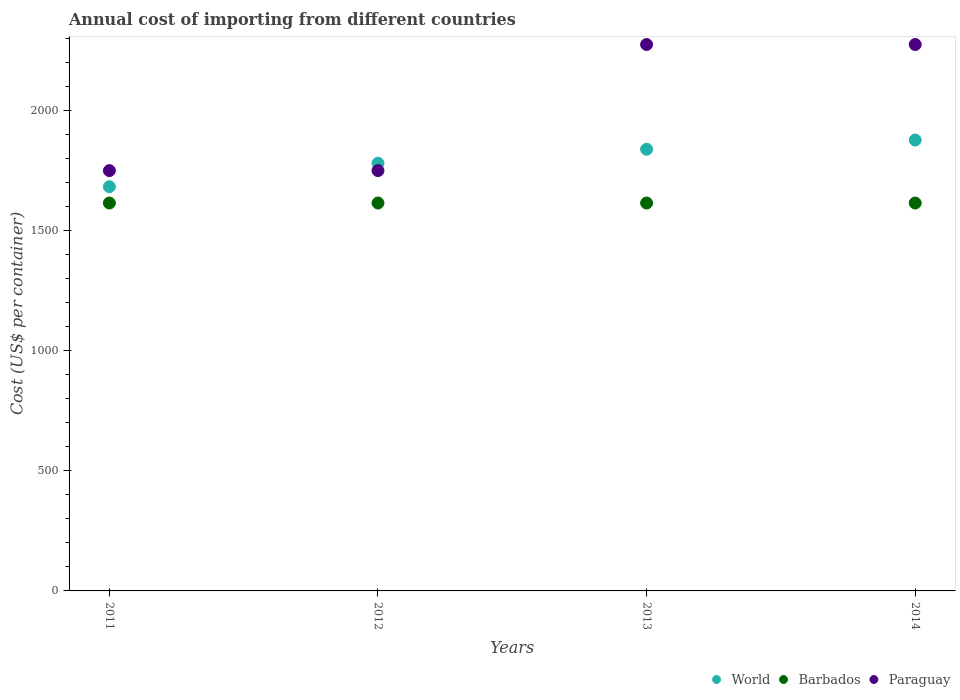How many different coloured dotlines are there?
Provide a short and direct response. 3. What is the total annual cost of importing in World in 2013?
Your answer should be compact. 1838.86. Across all years, what is the maximum total annual cost of importing in Paraguay?
Your response must be concise. 2275. Across all years, what is the minimum total annual cost of importing in Paraguay?
Your answer should be very brief. 1750. In which year was the total annual cost of importing in Paraguay minimum?
Give a very brief answer. 2011. What is the total total annual cost of importing in World in the graph?
Offer a terse response. 7179.65. What is the difference between the total annual cost of importing in World in 2012 and that in 2013?
Keep it short and to the point. -58.16. What is the difference between the total annual cost of importing in Barbados in 2013 and the total annual cost of importing in World in 2014?
Make the answer very short. -262.17. What is the average total annual cost of importing in Paraguay per year?
Your answer should be very brief. 2012.5. In the year 2012, what is the difference between the total annual cost of importing in World and total annual cost of importing in Barbados?
Offer a very short reply. 165.7. What is the ratio of the total annual cost of importing in World in 2011 to that in 2012?
Ensure brevity in your answer.  0.95. Is the difference between the total annual cost of importing in World in 2012 and 2013 greater than the difference between the total annual cost of importing in Barbados in 2012 and 2013?
Provide a succinct answer. No. What is the difference between the highest and the second highest total annual cost of importing in World?
Make the answer very short. 38.3. What is the difference between the highest and the lowest total annual cost of importing in World?
Make the answer very short. 194.24. Is the sum of the total annual cost of importing in Barbados in 2011 and 2012 greater than the maximum total annual cost of importing in World across all years?
Make the answer very short. Yes. Does the total annual cost of importing in World monotonically increase over the years?
Offer a very short reply. Yes. Is the total annual cost of importing in World strictly greater than the total annual cost of importing in Paraguay over the years?
Make the answer very short. No. How many dotlines are there?
Offer a very short reply. 3. What is the difference between two consecutive major ticks on the Y-axis?
Provide a succinct answer. 500. Does the graph contain any zero values?
Your response must be concise. No. Does the graph contain grids?
Offer a terse response. No. How many legend labels are there?
Give a very brief answer. 3. How are the legend labels stacked?
Your answer should be very brief. Horizontal. What is the title of the graph?
Offer a terse response. Annual cost of importing from different countries. What is the label or title of the Y-axis?
Ensure brevity in your answer.  Cost (US$ per container). What is the Cost (US$ per container) of World in 2011?
Make the answer very short. 1682.92. What is the Cost (US$ per container) of Barbados in 2011?
Provide a succinct answer. 1615. What is the Cost (US$ per container) in Paraguay in 2011?
Offer a terse response. 1750. What is the Cost (US$ per container) of World in 2012?
Make the answer very short. 1780.7. What is the Cost (US$ per container) of Barbados in 2012?
Keep it short and to the point. 1615. What is the Cost (US$ per container) of Paraguay in 2012?
Ensure brevity in your answer.  1750. What is the Cost (US$ per container) in World in 2013?
Make the answer very short. 1838.86. What is the Cost (US$ per container) in Barbados in 2013?
Your response must be concise. 1615. What is the Cost (US$ per container) in Paraguay in 2013?
Ensure brevity in your answer.  2275. What is the Cost (US$ per container) of World in 2014?
Give a very brief answer. 1877.17. What is the Cost (US$ per container) of Barbados in 2014?
Your answer should be very brief. 1615. What is the Cost (US$ per container) of Paraguay in 2014?
Offer a terse response. 2275. Across all years, what is the maximum Cost (US$ per container) of World?
Keep it short and to the point. 1877.17. Across all years, what is the maximum Cost (US$ per container) of Barbados?
Ensure brevity in your answer.  1615. Across all years, what is the maximum Cost (US$ per container) of Paraguay?
Your answer should be compact. 2275. Across all years, what is the minimum Cost (US$ per container) of World?
Your response must be concise. 1682.92. Across all years, what is the minimum Cost (US$ per container) of Barbados?
Offer a very short reply. 1615. Across all years, what is the minimum Cost (US$ per container) of Paraguay?
Provide a succinct answer. 1750. What is the total Cost (US$ per container) in World in the graph?
Offer a very short reply. 7179.65. What is the total Cost (US$ per container) of Barbados in the graph?
Offer a very short reply. 6460. What is the total Cost (US$ per container) in Paraguay in the graph?
Ensure brevity in your answer.  8050. What is the difference between the Cost (US$ per container) of World in 2011 and that in 2012?
Offer a terse response. -97.77. What is the difference between the Cost (US$ per container) of World in 2011 and that in 2013?
Ensure brevity in your answer.  -155.94. What is the difference between the Cost (US$ per container) of Barbados in 2011 and that in 2013?
Offer a terse response. 0. What is the difference between the Cost (US$ per container) in Paraguay in 2011 and that in 2013?
Your response must be concise. -525. What is the difference between the Cost (US$ per container) in World in 2011 and that in 2014?
Provide a short and direct response. -194.24. What is the difference between the Cost (US$ per container) of Paraguay in 2011 and that in 2014?
Keep it short and to the point. -525. What is the difference between the Cost (US$ per container) of World in 2012 and that in 2013?
Provide a succinct answer. -58.16. What is the difference between the Cost (US$ per container) in Barbados in 2012 and that in 2013?
Your answer should be very brief. 0. What is the difference between the Cost (US$ per container) of Paraguay in 2012 and that in 2013?
Offer a very short reply. -525. What is the difference between the Cost (US$ per container) in World in 2012 and that in 2014?
Your response must be concise. -96.47. What is the difference between the Cost (US$ per container) of Paraguay in 2012 and that in 2014?
Keep it short and to the point. -525. What is the difference between the Cost (US$ per container) of World in 2013 and that in 2014?
Ensure brevity in your answer.  -38.3. What is the difference between the Cost (US$ per container) in Paraguay in 2013 and that in 2014?
Your response must be concise. 0. What is the difference between the Cost (US$ per container) of World in 2011 and the Cost (US$ per container) of Barbados in 2012?
Ensure brevity in your answer.  67.92. What is the difference between the Cost (US$ per container) in World in 2011 and the Cost (US$ per container) in Paraguay in 2012?
Your response must be concise. -67.08. What is the difference between the Cost (US$ per container) of Barbados in 2011 and the Cost (US$ per container) of Paraguay in 2012?
Make the answer very short. -135. What is the difference between the Cost (US$ per container) in World in 2011 and the Cost (US$ per container) in Barbados in 2013?
Provide a short and direct response. 67.92. What is the difference between the Cost (US$ per container) in World in 2011 and the Cost (US$ per container) in Paraguay in 2013?
Your response must be concise. -592.08. What is the difference between the Cost (US$ per container) of Barbados in 2011 and the Cost (US$ per container) of Paraguay in 2013?
Offer a very short reply. -660. What is the difference between the Cost (US$ per container) in World in 2011 and the Cost (US$ per container) in Barbados in 2014?
Provide a short and direct response. 67.92. What is the difference between the Cost (US$ per container) of World in 2011 and the Cost (US$ per container) of Paraguay in 2014?
Keep it short and to the point. -592.08. What is the difference between the Cost (US$ per container) in Barbados in 2011 and the Cost (US$ per container) in Paraguay in 2014?
Your answer should be compact. -660. What is the difference between the Cost (US$ per container) in World in 2012 and the Cost (US$ per container) in Barbados in 2013?
Your response must be concise. 165.7. What is the difference between the Cost (US$ per container) in World in 2012 and the Cost (US$ per container) in Paraguay in 2013?
Your answer should be very brief. -494.3. What is the difference between the Cost (US$ per container) of Barbados in 2012 and the Cost (US$ per container) of Paraguay in 2013?
Your answer should be very brief. -660. What is the difference between the Cost (US$ per container) in World in 2012 and the Cost (US$ per container) in Barbados in 2014?
Give a very brief answer. 165.7. What is the difference between the Cost (US$ per container) in World in 2012 and the Cost (US$ per container) in Paraguay in 2014?
Provide a short and direct response. -494.3. What is the difference between the Cost (US$ per container) in Barbados in 2012 and the Cost (US$ per container) in Paraguay in 2014?
Make the answer very short. -660. What is the difference between the Cost (US$ per container) of World in 2013 and the Cost (US$ per container) of Barbados in 2014?
Your answer should be compact. 223.86. What is the difference between the Cost (US$ per container) in World in 2013 and the Cost (US$ per container) in Paraguay in 2014?
Keep it short and to the point. -436.14. What is the difference between the Cost (US$ per container) in Barbados in 2013 and the Cost (US$ per container) in Paraguay in 2014?
Make the answer very short. -660. What is the average Cost (US$ per container) in World per year?
Your response must be concise. 1794.91. What is the average Cost (US$ per container) of Barbados per year?
Offer a very short reply. 1615. What is the average Cost (US$ per container) of Paraguay per year?
Ensure brevity in your answer.  2012.5. In the year 2011, what is the difference between the Cost (US$ per container) in World and Cost (US$ per container) in Barbados?
Make the answer very short. 67.92. In the year 2011, what is the difference between the Cost (US$ per container) in World and Cost (US$ per container) in Paraguay?
Your response must be concise. -67.08. In the year 2011, what is the difference between the Cost (US$ per container) in Barbados and Cost (US$ per container) in Paraguay?
Provide a succinct answer. -135. In the year 2012, what is the difference between the Cost (US$ per container) in World and Cost (US$ per container) in Barbados?
Your answer should be compact. 165.7. In the year 2012, what is the difference between the Cost (US$ per container) in World and Cost (US$ per container) in Paraguay?
Keep it short and to the point. 30.7. In the year 2012, what is the difference between the Cost (US$ per container) in Barbados and Cost (US$ per container) in Paraguay?
Offer a terse response. -135. In the year 2013, what is the difference between the Cost (US$ per container) in World and Cost (US$ per container) in Barbados?
Keep it short and to the point. 223.86. In the year 2013, what is the difference between the Cost (US$ per container) in World and Cost (US$ per container) in Paraguay?
Offer a very short reply. -436.14. In the year 2013, what is the difference between the Cost (US$ per container) of Barbados and Cost (US$ per container) of Paraguay?
Provide a short and direct response. -660. In the year 2014, what is the difference between the Cost (US$ per container) of World and Cost (US$ per container) of Barbados?
Offer a very short reply. 262.17. In the year 2014, what is the difference between the Cost (US$ per container) of World and Cost (US$ per container) of Paraguay?
Provide a succinct answer. -397.83. In the year 2014, what is the difference between the Cost (US$ per container) in Barbados and Cost (US$ per container) in Paraguay?
Offer a very short reply. -660. What is the ratio of the Cost (US$ per container) in World in 2011 to that in 2012?
Provide a short and direct response. 0.95. What is the ratio of the Cost (US$ per container) of Barbados in 2011 to that in 2012?
Provide a succinct answer. 1. What is the ratio of the Cost (US$ per container) in World in 2011 to that in 2013?
Your response must be concise. 0.92. What is the ratio of the Cost (US$ per container) of Paraguay in 2011 to that in 2013?
Offer a terse response. 0.77. What is the ratio of the Cost (US$ per container) of World in 2011 to that in 2014?
Your answer should be compact. 0.9. What is the ratio of the Cost (US$ per container) of Barbados in 2011 to that in 2014?
Ensure brevity in your answer.  1. What is the ratio of the Cost (US$ per container) of Paraguay in 2011 to that in 2014?
Your answer should be compact. 0.77. What is the ratio of the Cost (US$ per container) of World in 2012 to that in 2013?
Provide a succinct answer. 0.97. What is the ratio of the Cost (US$ per container) of Paraguay in 2012 to that in 2013?
Your answer should be compact. 0.77. What is the ratio of the Cost (US$ per container) in World in 2012 to that in 2014?
Offer a terse response. 0.95. What is the ratio of the Cost (US$ per container) in Barbados in 2012 to that in 2014?
Your response must be concise. 1. What is the ratio of the Cost (US$ per container) of Paraguay in 2012 to that in 2014?
Offer a terse response. 0.77. What is the ratio of the Cost (US$ per container) in World in 2013 to that in 2014?
Your answer should be very brief. 0.98. What is the ratio of the Cost (US$ per container) in Barbados in 2013 to that in 2014?
Provide a succinct answer. 1. What is the ratio of the Cost (US$ per container) of Paraguay in 2013 to that in 2014?
Offer a very short reply. 1. What is the difference between the highest and the second highest Cost (US$ per container) in World?
Provide a short and direct response. 38.3. What is the difference between the highest and the lowest Cost (US$ per container) of World?
Make the answer very short. 194.24. What is the difference between the highest and the lowest Cost (US$ per container) of Paraguay?
Provide a short and direct response. 525. 